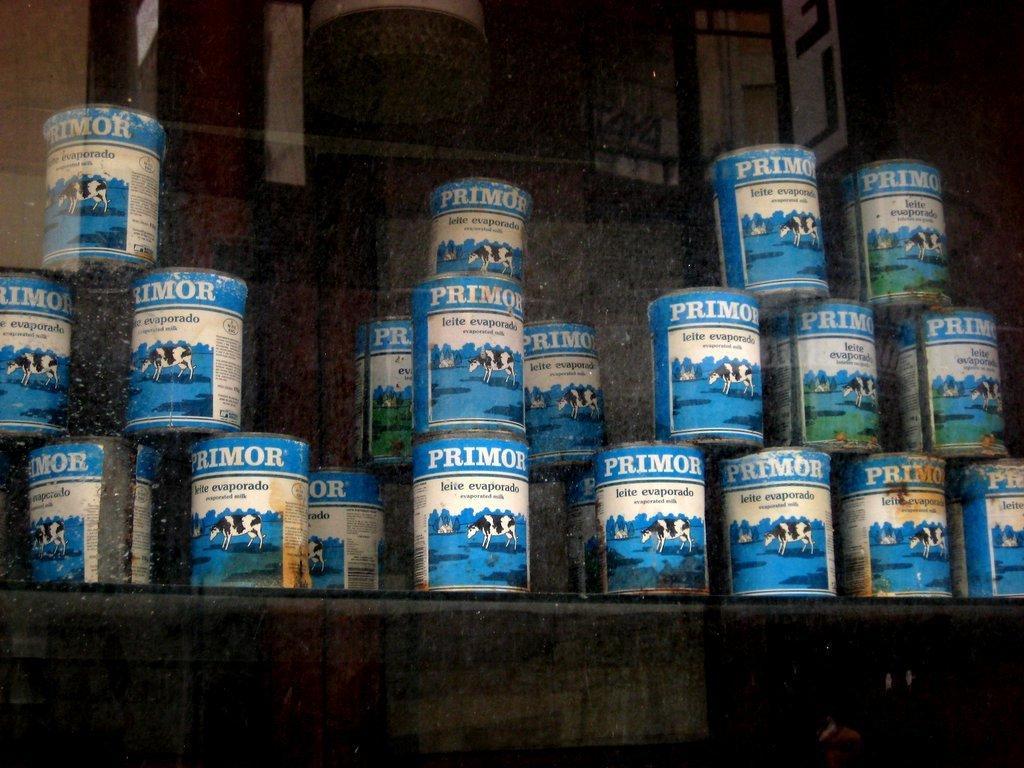Can you describe this image briefly? This image consists of boxes on a rack and a wall. This picture might be taken in a shop. 